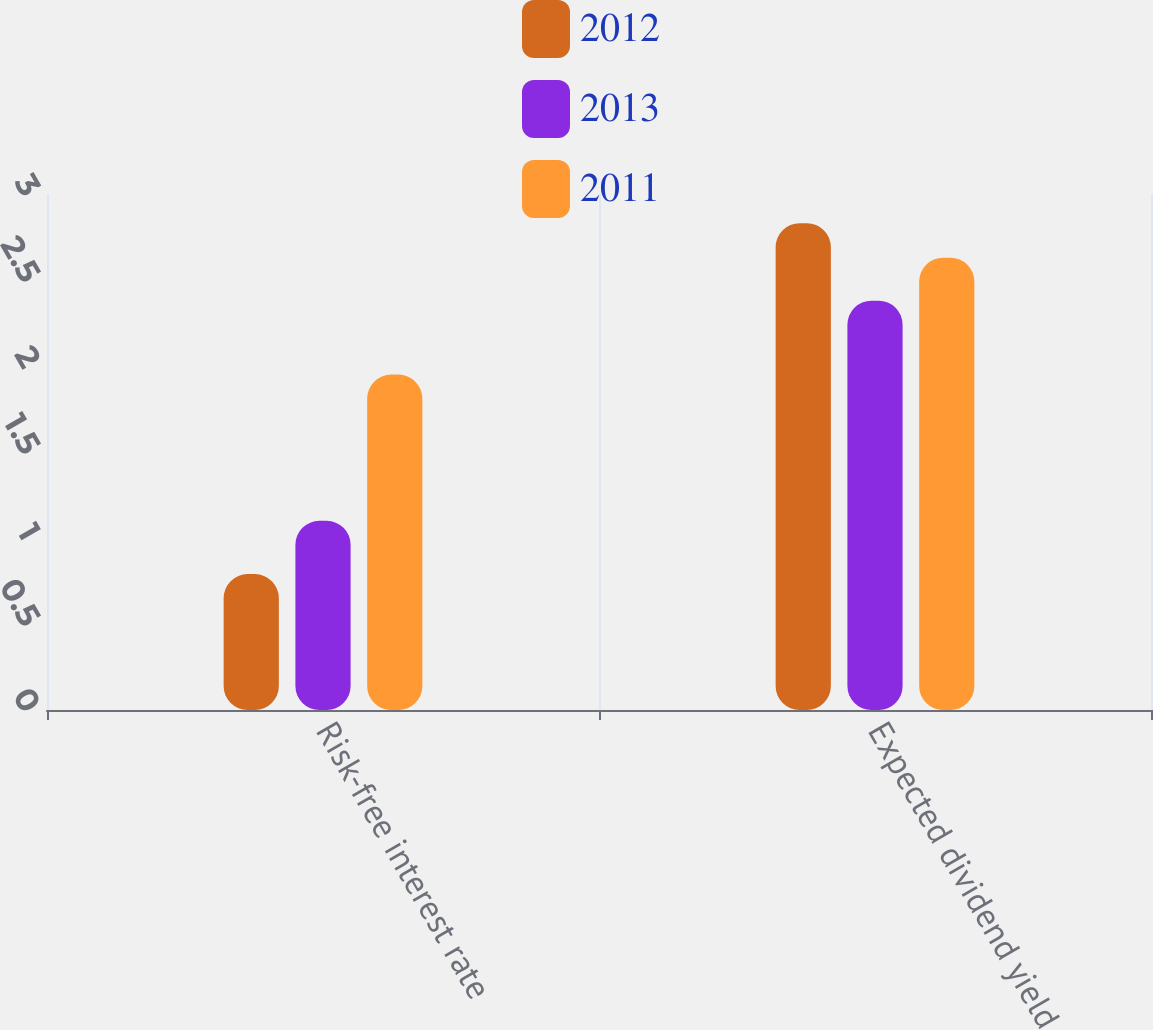Convert chart to OTSL. <chart><loc_0><loc_0><loc_500><loc_500><stacked_bar_chart><ecel><fcel>Risk-free interest rate<fcel>Expected dividend yield<nl><fcel>2012<fcel>0.79<fcel>2.83<nl><fcel>2013<fcel>1.1<fcel>2.38<nl><fcel>2011<fcel>1.95<fcel>2.63<nl></chart> 